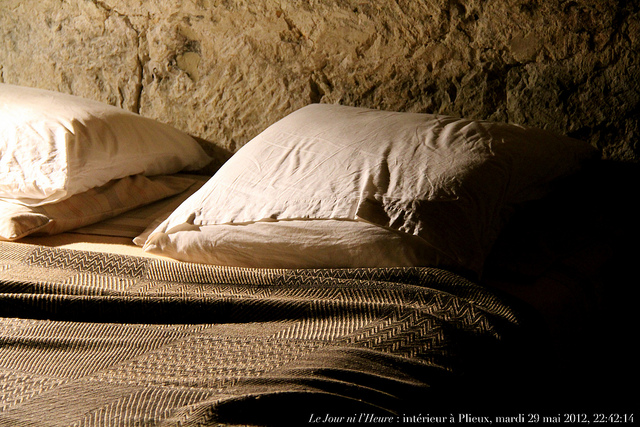Read and extract the text from this image. a 29 Jour mardi Plieux 14 12 22 2012. mai interieur Henre ni 